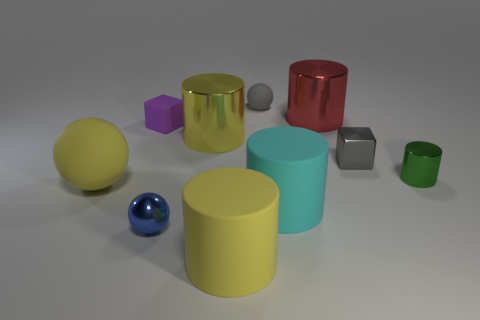Subtract all big red shiny cylinders. How many cylinders are left? 4 Subtract all gray blocks. How many blocks are left? 1 Add 3 big yellow metallic cylinders. How many big yellow metallic cylinders are left? 4 Add 4 large red shiny cylinders. How many large red shiny cylinders exist? 5 Subtract 1 blue balls. How many objects are left? 9 Subtract all spheres. How many objects are left? 7 Subtract 5 cylinders. How many cylinders are left? 0 Subtract all gray cubes. Subtract all gray cylinders. How many cubes are left? 1 Subtract all brown blocks. How many cyan cylinders are left? 1 Subtract all red spheres. Subtract all purple rubber cubes. How many objects are left? 9 